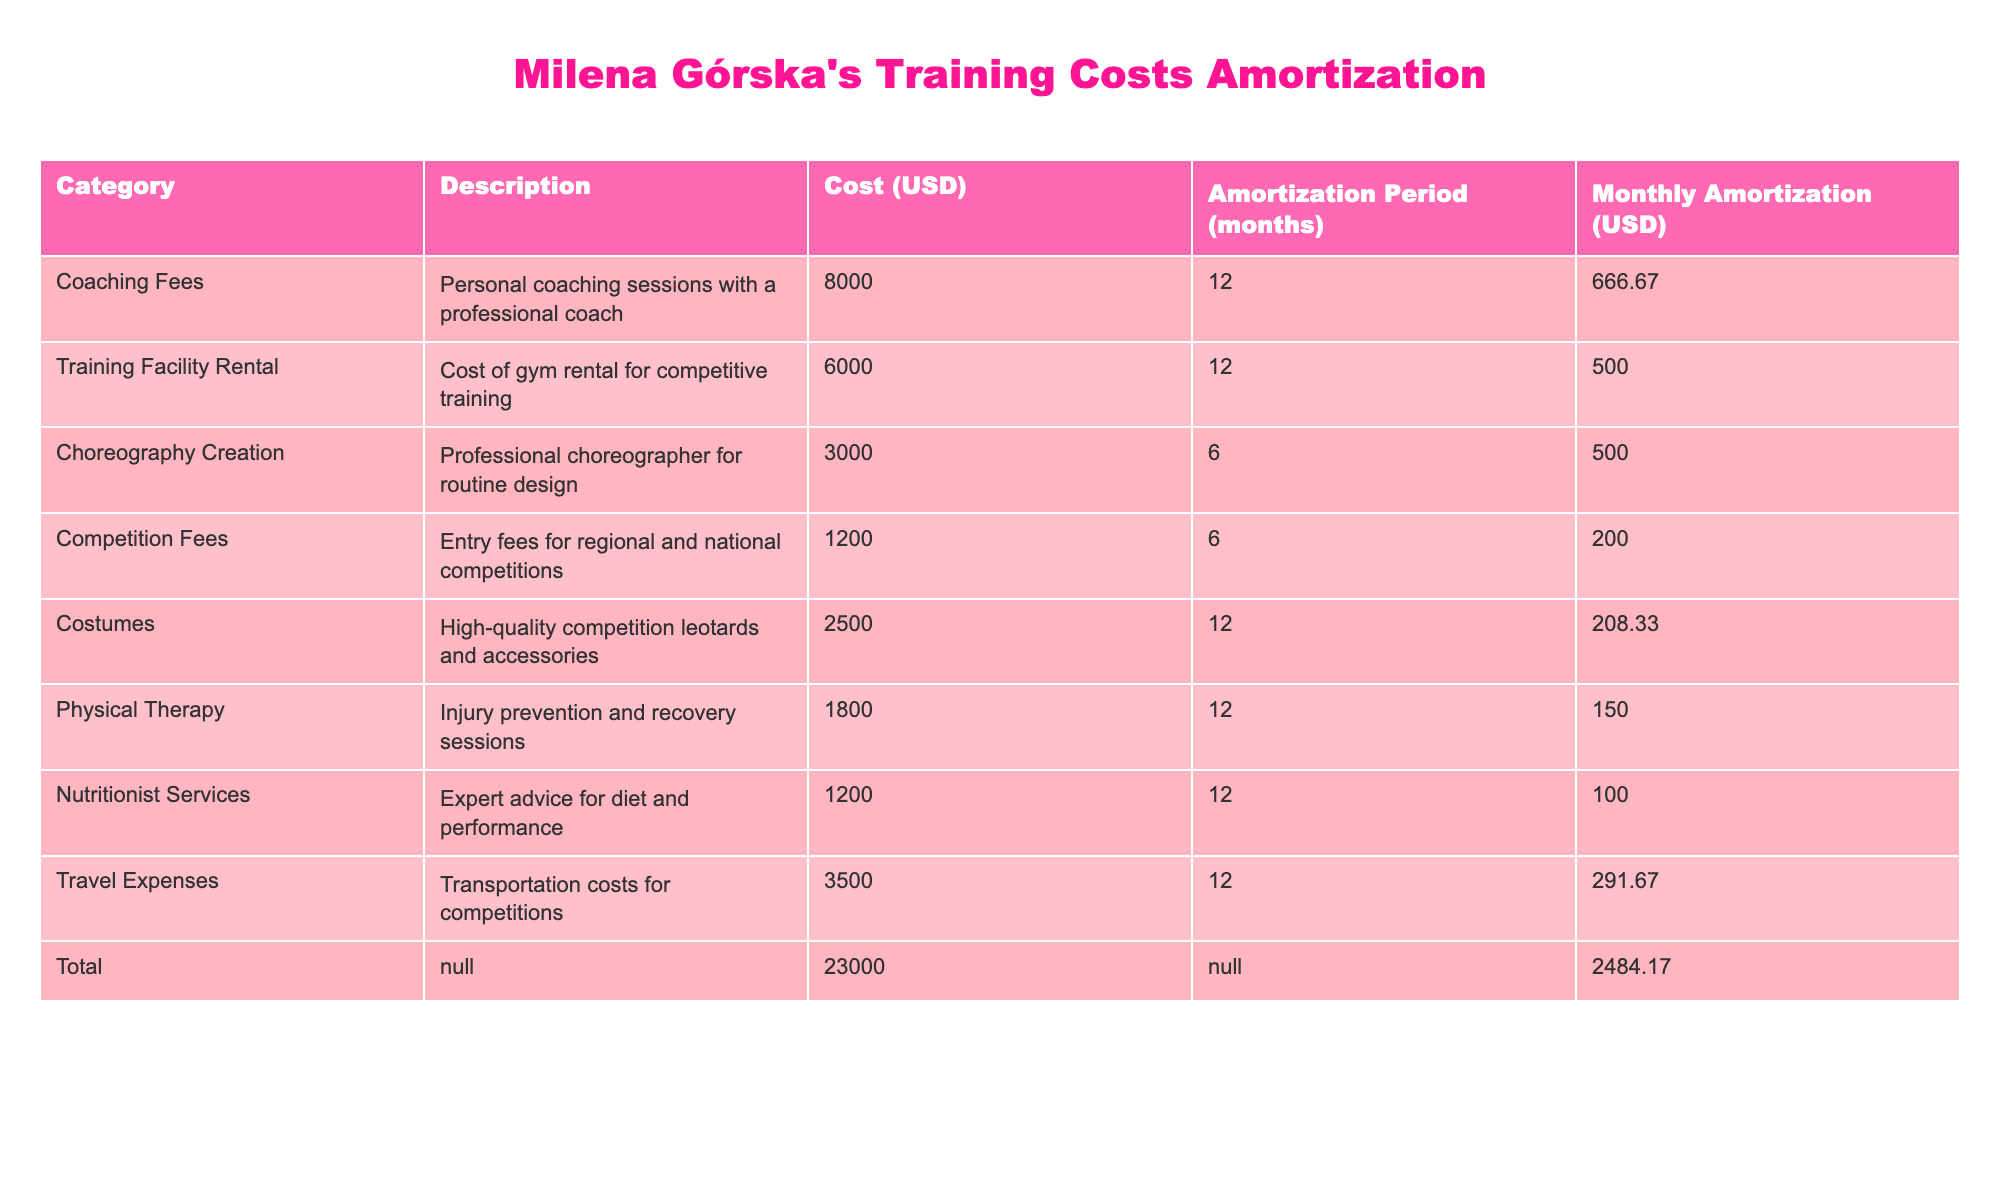What's the total cost associated with Milena Górska's training? The total cost is provided in the table under the "Total" row, which lists $23000 in the "Cost (USD)" column.
Answer: 23000 What is the monthly amortization cost for the physical therapy category? The table lists the monthly amortization for physical therapy as $150 in the "Monthly Amortization (USD)" column.
Answer: 150 How much does Milena spend on coaching fees each month? The coaching fees are $8000, and the amortization period is 12 months. Dividing gives 8000/12 = 666.67; thus, the monthly fee is $666.67.
Answer: 666.67 What is the total monthly amortization across all categories? The total monthly amortization is calculated by summing all the "Monthly Amortization (USD)" values, which equals $2484.17 as indicated in the table.
Answer: 2484.17 Is the cost of costumes more than the cost of competition fees? The table shows costumes at $2500 and competition fees at $1200. Since 2500 is greater than 1200, the answer is yes.
Answer: Yes What is the total amount spent on choreography creation and competition fees? Choreography creation costs $3000 and competition fees are $1200. Adding these two amounts together gives 3000 + 1200 = 4200.
Answer: 4200 How long is the amortization period for the training facility rental? The table states the amortization period for training facility rental as 12 months in the "Amortization Period (months)" column.
Answer: 12 Which category has the highest monthly amortization cost? Checking the "Monthly Amortization (USD)" column, coaching fees of $666.67 have the highest monthly amortization cost, which is confirmed by comparing all values in that column.
Answer: Coaching Fees If Milena wants to reduce her monthly training expenses by $500, which category should she consider reducing based on the table? A reduction could be considered from choreography creation, which has the lowest monthly amortization at $500. Reducing this expense would meet her target reduction.
Answer: Choreography Creation 